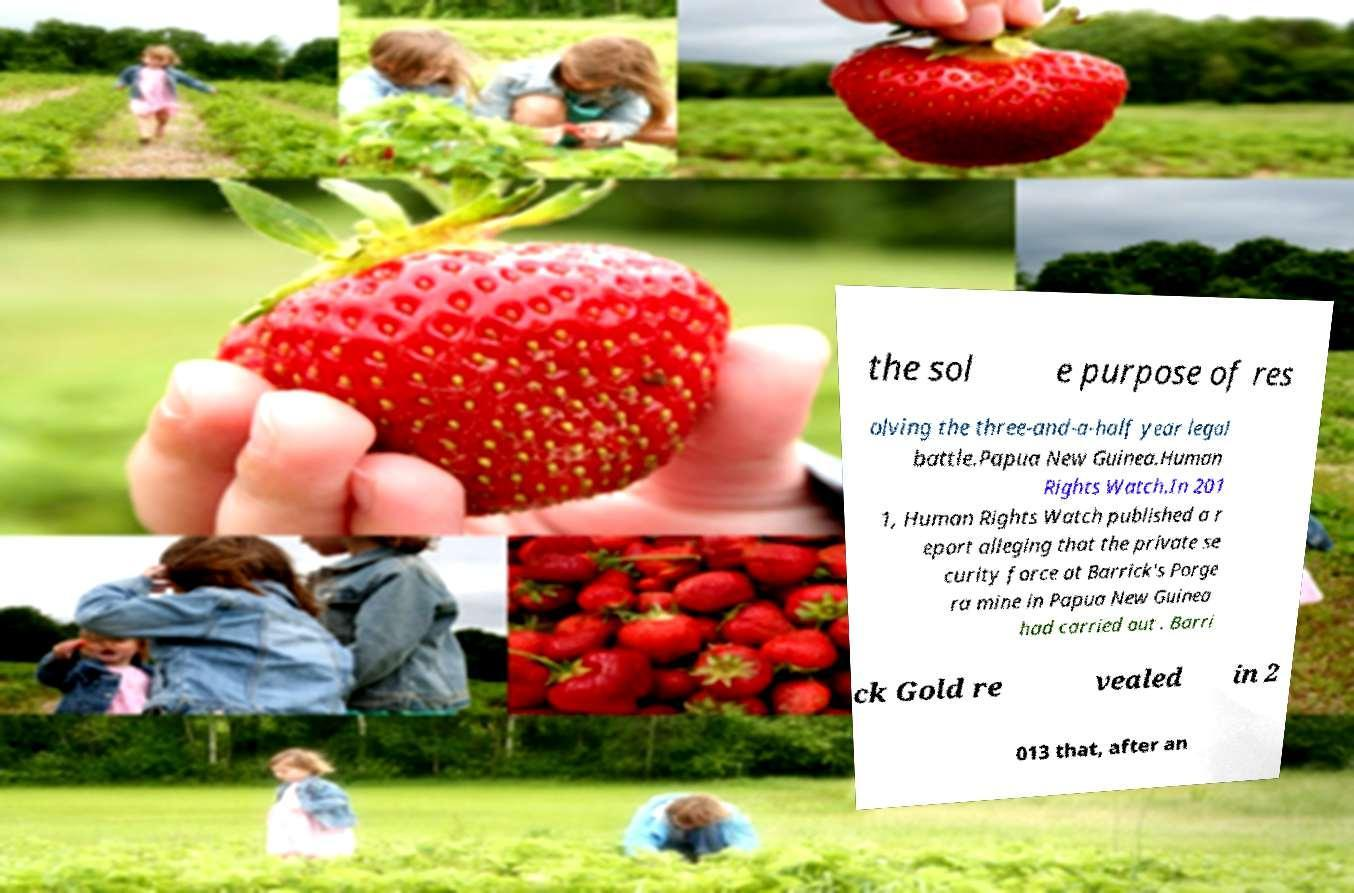Please identify and transcribe the text found in this image. the sol e purpose of res olving the three-and-a-half year legal battle.Papua New Guinea.Human Rights Watch.In 201 1, Human Rights Watch published a r eport alleging that the private se curity force at Barrick's Porge ra mine in Papua New Guinea had carried out . Barri ck Gold re vealed in 2 013 that, after an 